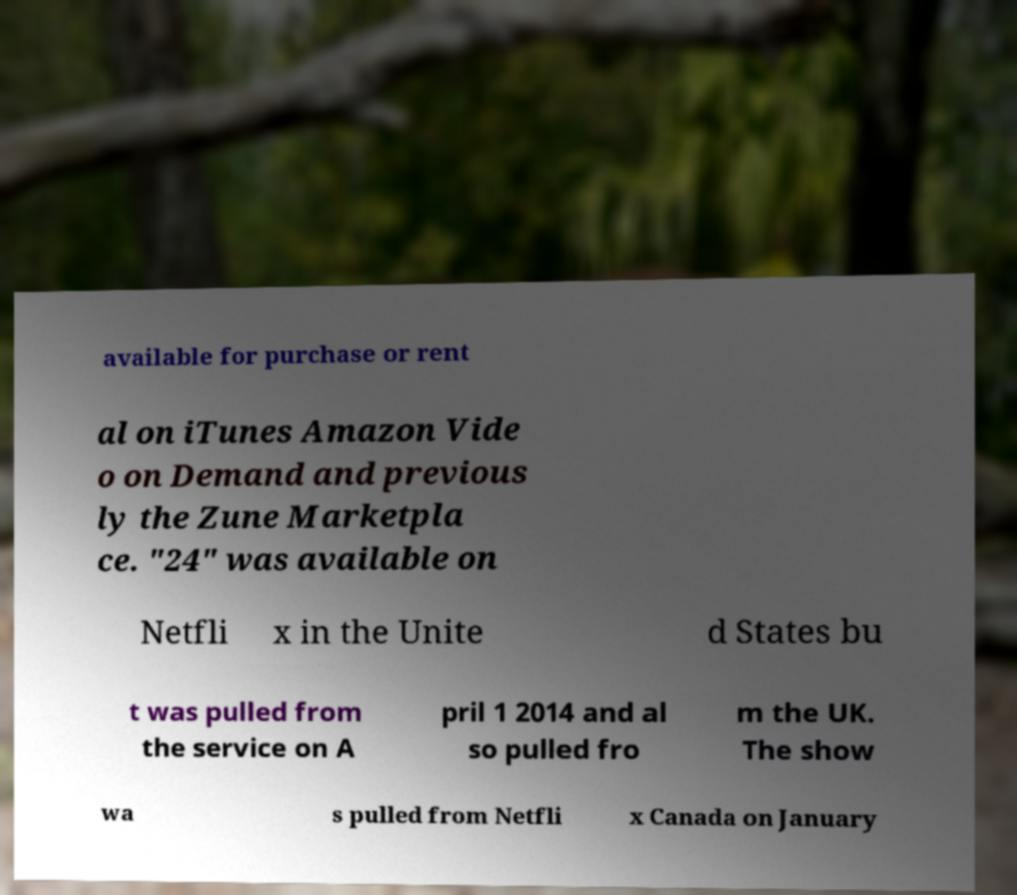Please identify and transcribe the text found in this image. available for purchase or rent al on iTunes Amazon Vide o on Demand and previous ly the Zune Marketpla ce. "24" was available on Netfli x in the Unite d States bu t was pulled from the service on A pril 1 2014 and al so pulled fro m the UK. The show wa s pulled from Netfli x Canada on January 